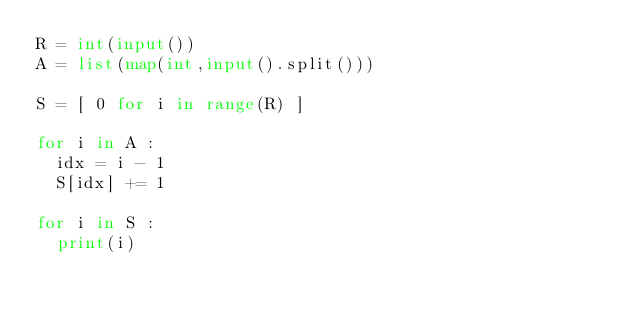Convert code to text. <code><loc_0><loc_0><loc_500><loc_500><_Python_>R = int(input())
A = list(map(int,input().split()))

S = [ 0 for i in range(R) ]

for i in A :
  idx = i - 1
  S[idx] += 1

for i in S :
  print(i)
</code> 